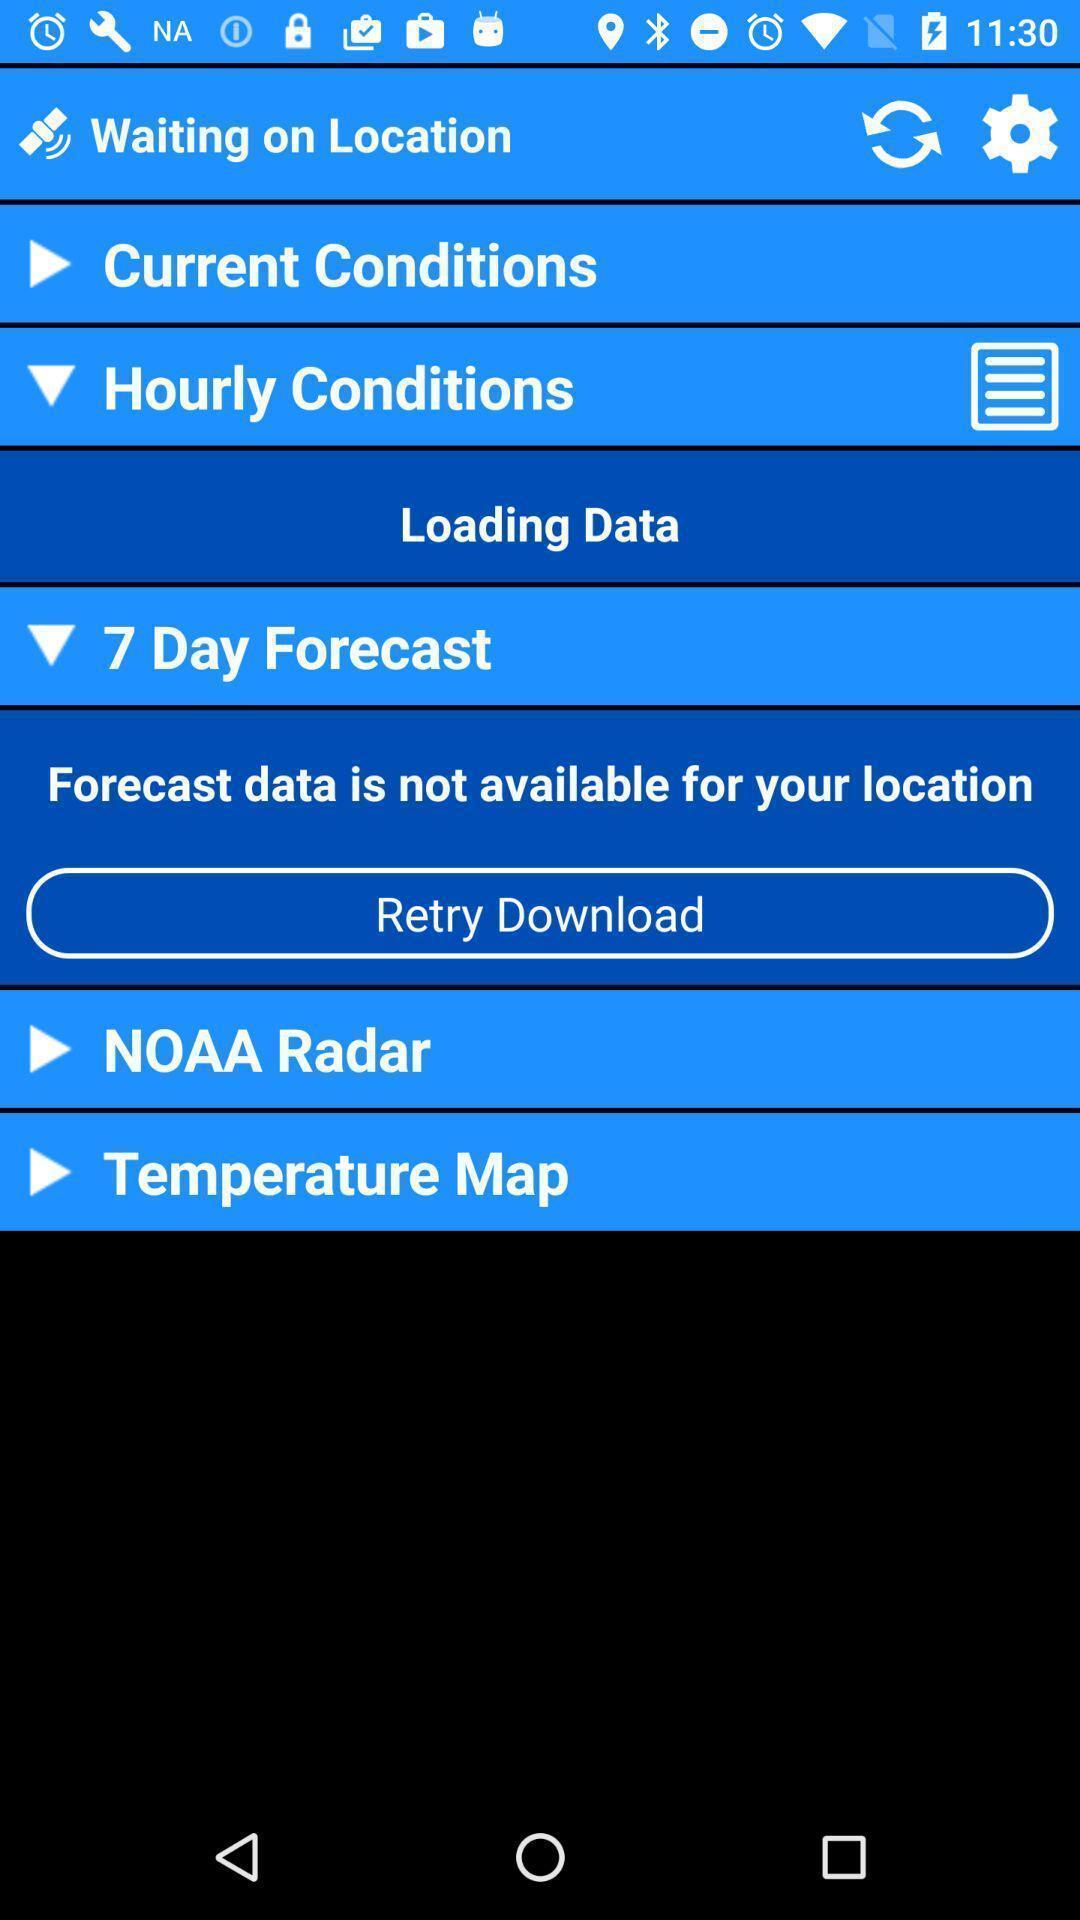What can you discern from this picture? Window displaying weather forecast app. 